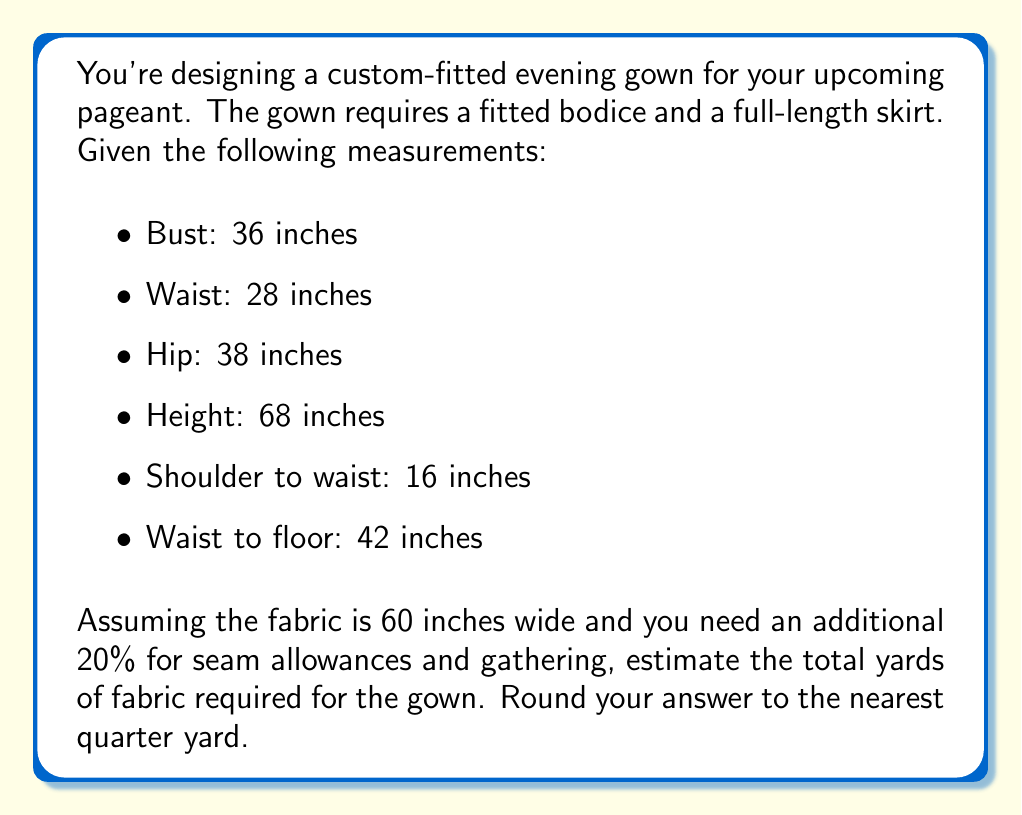Solve this math problem. Let's break this down step by step:

1. Calculate the bodice area:
   We'll use the largest measurement (bust) for the width and shoulder to waist for the length.
   Bodice area = $36 \text{ in} \times 16 \text{ in} = 576 \text{ sq in}$

2. Calculate the skirt area:
   We'll use the hip measurement for the width and waist to floor for the length.
   Skirt area = $38 \text{ in} \times 42 \text{ in} = 1596 \text{ sq in}$

3. Total fabric area needed:
   Total area = Bodice area + Skirt area
   $576 \text{ sq in} + 1596 \text{ sq in} = 2172 \text{ sq in}$

4. Add 20% for seam allowances and gathering:
   $2172 \text{ sq in} \times 1.2 = 2606.4 \text{ sq in}$

5. Convert to square yards:
   $2606.4 \text{ sq in} \div (36 \text{ in} \times 36 \text{ in}) = 2.01 \text{ sq yd}$

6. Calculate the length needed based on fabric width:
   $2.01 \text{ sq yd} \div (60 \text{ in} \div 36 \text{ in}) = 1.206 \text{ yd}$

7. Round to the nearest quarter yard:
   $1.206 \text{ yd} \approx 1.25 \text{ yd}$
Answer: 1.25 yards 